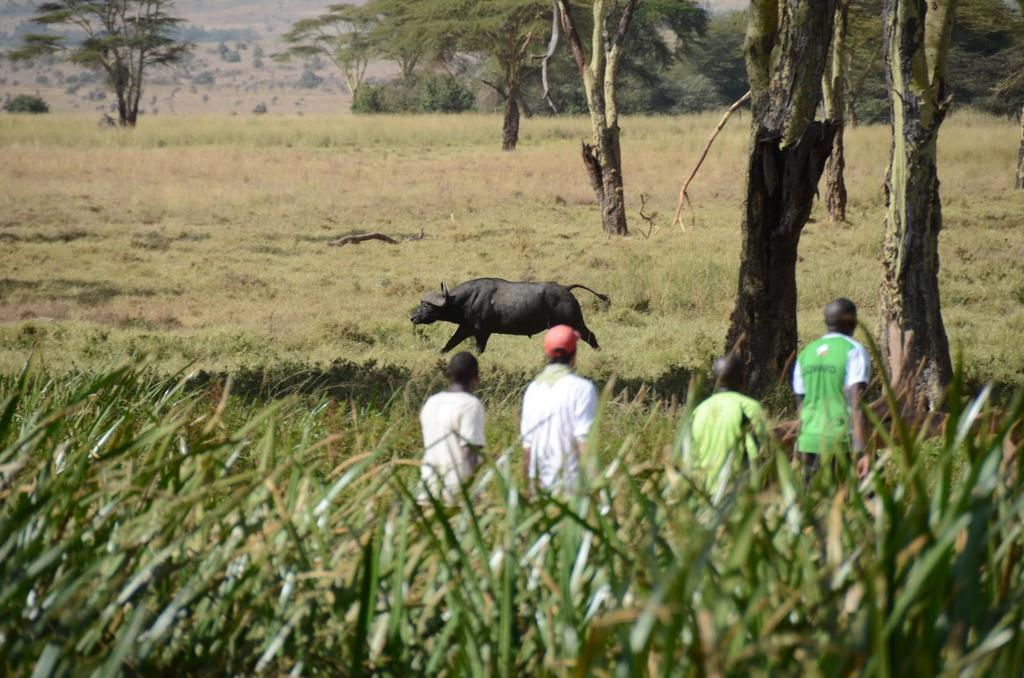What type of living organisms can be seen in the image? Plants and a group of people can be seen in the image. What is visible in the background of the image? Trees and a buffalo are visible in the background of the image. Where is the mailbox located in the image? There is no mailbox present in the image. Can you see any icicles hanging from the trees in the image? There is no mention of icicles in the image, and the presence of a buffalo in the background suggests a warmer climate where icicles are unlikely to form. 